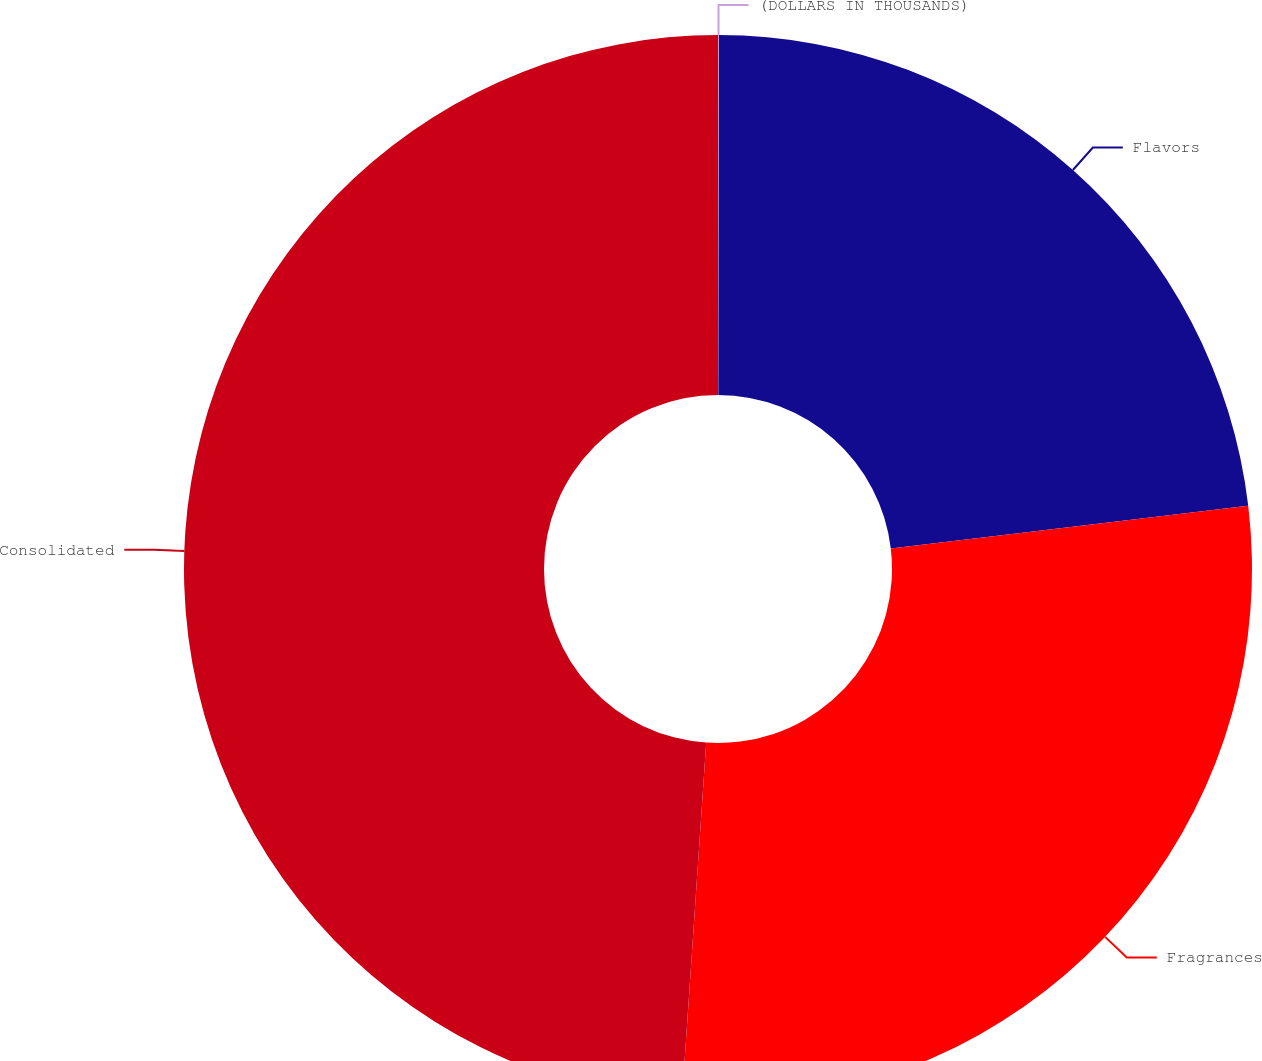Convert chart to OTSL. <chart><loc_0><loc_0><loc_500><loc_500><pie_chart><fcel>(DOLLARS IN THOUSANDS)<fcel>Flavors<fcel>Fragrances<fcel>Consolidated<nl><fcel>0.03%<fcel>23.08%<fcel>27.97%<fcel>48.92%<nl></chart> 